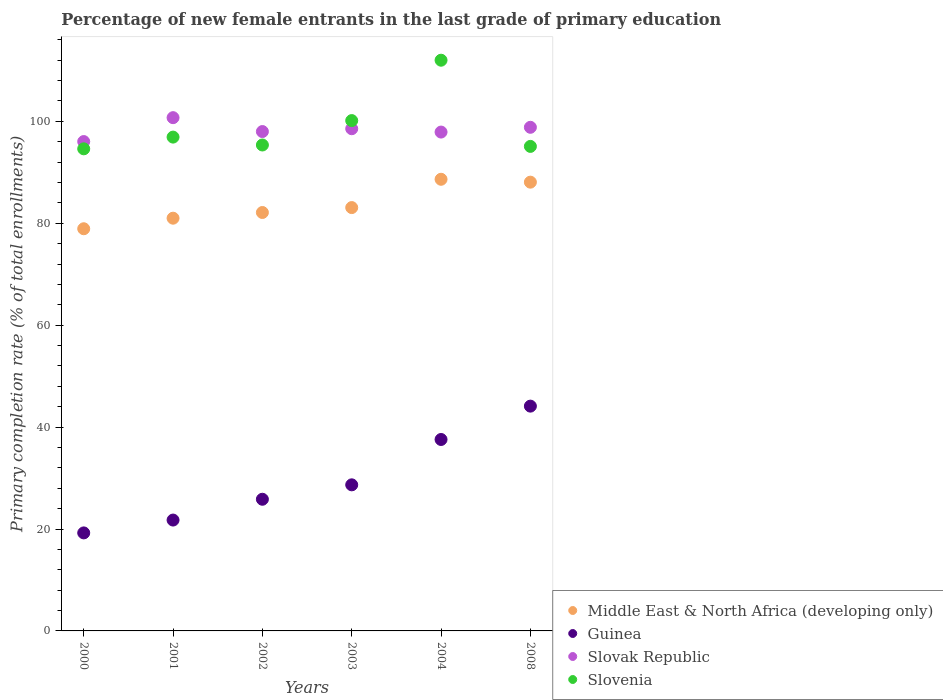How many different coloured dotlines are there?
Give a very brief answer. 4. What is the percentage of new female entrants in Middle East & North Africa (developing only) in 2001?
Your answer should be compact. 80.99. Across all years, what is the maximum percentage of new female entrants in Middle East & North Africa (developing only)?
Offer a terse response. 88.63. Across all years, what is the minimum percentage of new female entrants in Slovak Republic?
Make the answer very short. 96.03. In which year was the percentage of new female entrants in Slovenia maximum?
Give a very brief answer. 2004. What is the total percentage of new female entrants in Slovak Republic in the graph?
Make the answer very short. 590.02. What is the difference between the percentage of new female entrants in Middle East & North Africa (developing only) in 2003 and that in 2004?
Make the answer very short. -5.56. What is the difference between the percentage of new female entrants in Guinea in 2001 and the percentage of new female entrants in Middle East & North Africa (developing only) in 2000?
Your answer should be very brief. -57.17. What is the average percentage of new female entrants in Middle East & North Africa (developing only) per year?
Keep it short and to the point. 83.63. In the year 2008, what is the difference between the percentage of new female entrants in Guinea and percentage of new female entrants in Slovenia?
Your answer should be very brief. -50.97. In how many years, is the percentage of new female entrants in Slovak Republic greater than 20 %?
Provide a succinct answer. 6. What is the ratio of the percentage of new female entrants in Slovenia in 2003 to that in 2004?
Your answer should be compact. 0.89. Is the difference between the percentage of new female entrants in Guinea in 2000 and 2008 greater than the difference between the percentage of new female entrants in Slovenia in 2000 and 2008?
Offer a very short reply. No. What is the difference between the highest and the second highest percentage of new female entrants in Middle East & North Africa (developing only)?
Provide a short and direct response. 0.57. What is the difference between the highest and the lowest percentage of new female entrants in Middle East & North Africa (developing only)?
Your answer should be very brief. 9.71. Is it the case that in every year, the sum of the percentage of new female entrants in Guinea and percentage of new female entrants in Middle East & North Africa (developing only)  is greater than the sum of percentage of new female entrants in Slovak Republic and percentage of new female entrants in Slovenia?
Offer a terse response. No. Is it the case that in every year, the sum of the percentage of new female entrants in Middle East & North Africa (developing only) and percentage of new female entrants in Slovenia  is greater than the percentage of new female entrants in Slovak Republic?
Provide a short and direct response. Yes. Does the percentage of new female entrants in Slovenia monotonically increase over the years?
Offer a very short reply. No. Is the percentage of new female entrants in Slovak Republic strictly greater than the percentage of new female entrants in Slovenia over the years?
Ensure brevity in your answer.  No. Is the percentage of new female entrants in Slovak Republic strictly less than the percentage of new female entrants in Slovenia over the years?
Your response must be concise. No. How many dotlines are there?
Your answer should be very brief. 4. What is the difference between two consecutive major ticks on the Y-axis?
Offer a very short reply. 20. Are the values on the major ticks of Y-axis written in scientific E-notation?
Provide a short and direct response. No. Does the graph contain any zero values?
Offer a very short reply. No. Does the graph contain grids?
Provide a succinct answer. No. Where does the legend appear in the graph?
Your response must be concise. Bottom right. How many legend labels are there?
Your response must be concise. 4. How are the legend labels stacked?
Keep it short and to the point. Vertical. What is the title of the graph?
Make the answer very short. Percentage of new female entrants in the last grade of primary education. Does "Cambodia" appear as one of the legend labels in the graph?
Provide a short and direct response. No. What is the label or title of the X-axis?
Your answer should be compact. Years. What is the label or title of the Y-axis?
Your answer should be compact. Primary completion rate (% of total enrollments). What is the Primary completion rate (% of total enrollments) of Middle East & North Africa (developing only) in 2000?
Provide a short and direct response. 78.92. What is the Primary completion rate (% of total enrollments) of Guinea in 2000?
Offer a terse response. 19.23. What is the Primary completion rate (% of total enrollments) of Slovak Republic in 2000?
Keep it short and to the point. 96.03. What is the Primary completion rate (% of total enrollments) of Slovenia in 2000?
Ensure brevity in your answer.  94.61. What is the Primary completion rate (% of total enrollments) in Middle East & North Africa (developing only) in 2001?
Provide a succinct answer. 80.99. What is the Primary completion rate (% of total enrollments) of Guinea in 2001?
Give a very brief answer. 21.75. What is the Primary completion rate (% of total enrollments) in Slovak Republic in 2001?
Offer a very short reply. 100.72. What is the Primary completion rate (% of total enrollments) of Slovenia in 2001?
Provide a short and direct response. 96.91. What is the Primary completion rate (% of total enrollments) of Middle East & North Africa (developing only) in 2002?
Your answer should be very brief. 82.11. What is the Primary completion rate (% of total enrollments) in Guinea in 2002?
Ensure brevity in your answer.  25.84. What is the Primary completion rate (% of total enrollments) of Slovak Republic in 2002?
Offer a terse response. 98. What is the Primary completion rate (% of total enrollments) in Slovenia in 2002?
Make the answer very short. 95.36. What is the Primary completion rate (% of total enrollments) in Middle East & North Africa (developing only) in 2003?
Make the answer very short. 83.07. What is the Primary completion rate (% of total enrollments) in Guinea in 2003?
Keep it short and to the point. 28.67. What is the Primary completion rate (% of total enrollments) in Slovak Republic in 2003?
Your answer should be very brief. 98.55. What is the Primary completion rate (% of total enrollments) of Slovenia in 2003?
Offer a very short reply. 100.15. What is the Primary completion rate (% of total enrollments) of Middle East & North Africa (developing only) in 2004?
Your answer should be very brief. 88.63. What is the Primary completion rate (% of total enrollments) of Guinea in 2004?
Offer a terse response. 37.57. What is the Primary completion rate (% of total enrollments) of Slovak Republic in 2004?
Provide a succinct answer. 97.89. What is the Primary completion rate (% of total enrollments) in Slovenia in 2004?
Provide a succinct answer. 112. What is the Primary completion rate (% of total enrollments) of Middle East & North Africa (developing only) in 2008?
Make the answer very short. 88.06. What is the Primary completion rate (% of total enrollments) of Guinea in 2008?
Make the answer very short. 44.11. What is the Primary completion rate (% of total enrollments) of Slovak Republic in 2008?
Give a very brief answer. 98.83. What is the Primary completion rate (% of total enrollments) in Slovenia in 2008?
Ensure brevity in your answer.  95.08. Across all years, what is the maximum Primary completion rate (% of total enrollments) of Middle East & North Africa (developing only)?
Your response must be concise. 88.63. Across all years, what is the maximum Primary completion rate (% of total enrollments) in Guinea?
Your answer should be very brief. 44.11. Across all years, what is the maximum Primary completion rate (% of total enrollments) in Slovak Republic?
Ensure brevity in your answer.  100.72. Across all years, what is the maximum Primary completion rate (% of total enrollments) of Slovenia?
Offer a terse response. 112. Across all years, what is the minimum Primary completion rate (% of total enrollments) of Middle East & North Africa (developing only)?
Your answer should be very brief. 78.92. Across all years, what is the minimum Primary completion rate (% of total enrollments) of Guinea?
Ensure brevity in your answer.  19.23. Across all years, what is the minimum Primary completion rate (% of total enrollments) in Slovak Republic?
Provide a succinct answer. 96.03. Across all years, what is the minimum Primary completion rate (% of total enrollments) of Slovenia?
Keep it short and to the point. 94.61. What is the total Primary completion rate (% of total enrollments) in Middle East & North Africa (developing only) in the graph?
Ensure brevity in your answer.  501.79. What is the total Primary completion rate (% of total enrollments) of Guinea in the graph?
Offer a very short reply. 177.17. What is the total Primary completion rate (% of total enrollments) of Slovak Republic in the graph?
Give a very brief answer. 590.02. What is the total Primary completion rate (% of total enrollments) in Slovenia in the graph?
Your answer should be compact. 594.09. What is the difference between the Primary completion rate (% of total enrollments) of Middle East & North Africa (developing only) in 2000 and that in 2001?
Ensure brevity in your answer.  -2.07. What is the difference between the Primary completion rate (% of total enrollments) in Guinea in 2000 and that in 2001?
Your answer should be compact. -2.52. What is the difference between the Primary completion rate (% of total enrollments) in Slovak Republic in 2000 and that in 2001?
Your answer should be compact. -4.69. What is the difference between the Primary completion rate (% of total enrollments) of Slovenia in 2000 and that in 2001?
Give a very brief answer. -2.3. What is the difference between the Primary completion rate (% of total enrollments) in Middle East & North Africa (developing only) in 2000 and that in 2002?
Give a very brief answer. -3.19. What is the difference between the Primary completion rate (% of total enrollments) of Guinea in 2000 and that in 2002?
Your answer should be very brief. -6.6. What is the difference between the Primary completion rate (% of total enrollments) in Slovak Republic in 2000 and that in 2002?
Provide a succinct answer. -1.97. What is the difference between the Primary completion rate (% of total enrollments) in Slovenia in 2000 and that in 2002?
Your response must be concise. -0.75. What is the difference between the Primary completion rate (% of total enrollments) of Middle East & North Africa (developing only) in 2000 and that in 2003?
Provide a short and direct response. -4.15. What is the difference between the Primary completion rate (% of total enrollments) in Guinea in 2000 and that in 2003?
Your answer should be very brief. -9.43. What is the difference between the Primary completion rate (% of total enrollments) of Slovak Republic in 2000 and that in 2003?
Give a very brief answer. -2.52. What is the difference between the Primary completion rate (% of total enrollments) in Slovenia in 2000 and that in 2003?
Keep it short and to the point. -5.54. What is the difference between the Primary completion rate (% of total enrollments) in Middle East & North Africa (developing only) in 2000 and that in 2004?
Keep it short and to the point. -9.71. What is the difference between the Primary completion rate (% of total enrollments) of Guinea in 2000 and that in 2004?
Your answer should be very brief. -18.33. What is the difference between the Primary completion rate (% of total enrollments) in Slovak Republic in 2000 and that in 2004?
Provide a succinct answer. -1.86. What is the difference between the Primary completion rate (% of total enrollments) in Slovenia in 2000 and that in 2004?
Provide a succinct answer. -17.39. What is the difference between the Primary completion rate (% of total enrollments) in Middle East & North Africa (developing only) in 2000 and that in 2008?
Your answer should be compact. -9.14. What is the difference between the Primary completion rate (% of total enrollments) in Guinea in 2000 and that in 2008?
Provide a succinct answer. -24.88. What is the difference between the Primary completion rate (% of total enrollments) of Slovak Republic in 2000 and that in 2008?
Offer a very short reply. -2.8. What is the difference between the Primary completion rate (% of total enrollments) of Slovenia in 2000 and that in 2008?
Provide a short and direct response. -0.48. What is the difference between the Primary completion rate (% of total enrollments) of Middle East & North Africa (developing only) in 2001 and that in 2002?
Provide a short and direct response. -1.12. What is the difference between the Primary completion rate (% of total enrollments) of Guinea in 2001 and that in 2002?
Your answer should be compact. -4.08. What is the difference between the Primary completion rate (% of total enrollments) in Slovak Republic in 2001 and that in 2002?
Give a very brief answer. 2.72. What is the difference between the Primary completion rate (% of total enrollments) in Slovenia in 2001 and that in 2002?
Your response must be concise. 1.55. What is the difference between the Primary completion rate (% of total enrollments) of Middle East & North Africa (developing only) in 2001 and that in 2003?
Your response must be concise. -2.08. What is the difference between the Primary completion rate (% of total enrollments) of Guinea in 2001 and that in 2003?
Your response must be concise. -6.91. What is the difference between the Primary completion rate (% of total enrollments) in Slovak Republic in 2001 and that in 2003?
Give a very brief answer. 2.17. What is the difference between the Primary completion rate (% of total enrollments) of Slovenia in 2001 and that in 2003?
Your response must be concise. -3.24. What is the difference between the Primary completion rate (% of total enrollments) in Middle East & North Africa (developing only) in 2001 and that in 2004?
Give a very brief answer. -7.64. What is the difference between the Primary completion rate (% of total enrollments) of Guinea in 2001 and that in 2004?
Ensure brevity in your answer.  -15.81. What is the difference between the Primary completion rate (% of total enrollments) in Slovak Republic in 2001 and that in 2004?
Ensure brevity in your answer.  2.83. What is the difference between the Primary completion rate (% of total enrollments) of Slovenia in 2001 and that in 2004?
Keep it short and to the point. -15.09. What is the difference between the Primary completion rate (% of total enrollments) in Middle East & North Africa (developing only) in 2001 and that in 2008?
Give a very brief answer. -7.07. What is the difference between the Primary completion rate (% of total enrollments) in Guinea in 2001 and that in 2008?
Provide a succinct answer. -22.36. What is the difference between the Primary completion rate (% of total enrollments) of Slovak Republic in 2001 and that in 2008?
Your answer should be very brief. 1.89. What is the difference between the Primary completion rate (% of total enrollments) of Slovenia in 2001 and that in 2008?
Provide a succinct answer. 1.82. What is the difference between the Primary completion rate (% of total enrollments) in Middle East & North Africa (developing only) in 2002 and that in 2003?
Offer a very short reply. -0.96. What is the difference between the Primary completion rate (% of total enrollments) of Guinea in 2002 and that in 2003?
Keep it short and to the point. -2.83. What is the difference between the Primary completion rate (% of total enrollments) of Slovak Republic in 2002 and that in 2003?
Provide a succinct answer. -0.55. What is the difference between the Primary completion rate (% of total enrollments) of Slovenia in 2002 and that in 2003?
Make the answer very short. -4.79. What is the difference between the Primary completion rate (% of total enrollments) in Middle East & North Africa (developing only) in 2002 and that in 2004?
Your response must be concise. -6.52. What is the difference between the Primary completion rate (% of total enrollments) of Guinea in 2002 and that in 2004?
Keep it short and to the point. -11.73. What is the difference between the Primary completion rate (% of total enrollments) of Slovak Republic in 2002 and that in 2004?
Offer a terse response. 0.1. What is the difference between the Primary completion rate (% of total enrollments) of Slovenia in 2002 and that in 2004?
Your answer should be compact. -16.64. What is the difference between the Primary completion rate (% of total enrollments) in Middle East & North Africa (developing only) in 2002 and that in 2008?
Offer a terse response. -5.95. What is the difference between the Primary completion rate (% of total enrollments) of Guinea in 2002 and that in 2008?
Offer a terse response. -18.27. What is the difference between the Primary completion rate (% of total enrollments) of Slovak Republic in 2002 and that in 2008?
Offer a terse response. -0.83. What is the difference between the Primary completion rate (% of total enrollments) in Slovenia in 2002 and that in 2008?
Keep it short and to the point. 0.28. What is the difference between the Primary completion rate (% of total enrollments) in Middle East & North Africa (developing only) in 2003 and that in 2004?
Provide a succinct answer. -5.56. What is the difference between the Primary completion rate (% of total enrollments) in Guinea in 2003 and that in 2004?
Keep it short and to the point. -8.9. What is the difference between the Primary completion rate (% of total enrollments) of Slovak Republic in 2003 and that in 2004?
Your answer should be very brief. 0.65. What is the difference between the Primary completion rate (% of total enrollments) in Slovenia in 2003 and that in 2004?
Provide a short and direct response. -11.85. What is the difference between the Primary completion rate (% of total enrollments) in Middle East & North Africa (developing only) in 2003 and that in 2008?
Keep it short and to the point. -4.99. What is the difference between the Primary completion rate (% of total enrollments) of Guinea in 2003 and that in 2008?
Your answer should be compact. -15.44. What is the difference between the Primary completion rate (% of total enrollments) of Slovak Republic in 2003 and that in 2008?
Provide a short and direct response. -0.28. What is the difference between the Primary completion rate (% of total enrollments) in Slovenia in 2003 and that in 2008?
Give a very brief answer. 5.06. What is the difference between the Primary completion rate (% of total enrollments) of Middle East & North Africa (developing only) in 2004 and that in 2008?
Make the answer very short. 0.57. What is the difference between the Primary completion rate (% of total enrollments) in Guinea in 2004 and that in 2008?
Make the answer very short. -6.54. What is the difference between the Primary completion rate (% of total enrollments) of Slovak Republic in 2004 and that in 2008?
Keep it short and to the point. -0.94. What is the difference between the Primary completion rate (% of total enrollments) in Slovenia in 2004 and that in 2008?
Give a very brief answer. 16.91. What is the difference between the Primary completion rate (% of total enrollments) in Middle East & North Africa (developing only) in 2000 and the Primary completion rate (% of total enrollments) in Guinea in 2001?
Make the answer very short. 57.17. What is the difference between the Primary completion rate (% of total enrollments) in Middle East & North Africa (developing only) in 2000 and the Primary completion rate (% of total enrollments) in Slovak Republic in 2001?
Provide a succinct answer. -21.8. What is the difference between the Primary completion rate (% of total enrollments) in Middle East & North Africa (developing only) in 2000 and the Primary completion rate (% of total enrollments) in Slovenia in 2001?
Your answer should be very brief. -17.98. What is the difference between the Primary completion rate (% of total enrollments) of Guinea in 2000 and the Primary completion rate (% of total enrollments) of Slovak Republic in 2001?
Provide a short and direct response. -81.49. What is the difference between the Primary completion rate (% of total enrollments) in Guinea in 2000 and the Primary completion rate (% of total enrollments) in Slovenia in 2001?
Your answer should be compact. -77.67. What is the difference between the Primary completion rate (% of total enrollments) of Slovak Republic in 2000 and the Primary completion rate (% of total enrollments) of Slovenia in 2001?
Give a very brief answer. -0.88. What is the difference between the Primary completion rate (% of total enrollments) in Middle East & North Africa (developing only) in 2000 and the Primary completion rate (% of total enrollments) in Guinea in 2002?
Your response must be concise. 53.08. What is the difference between the Primary completion rate (% of total enrollments) in Middle East & North Africa (developing only) in 2000 and the Primary completion rate (% of total enrollments) in Slovak Republic in 2002?
Provide a short and direct response. -19.07. What is the difference between the Primary completion rate (% of total enrollments) in Middle East & North Africa (developing only) in 2000 and the Primary completion rate (% of total enrollments) in Slovenia in 2002?
Keep it short and to the point. -16.44. What is the difference between the Primary completion rate (% of total enrollments) in Guinea in 2000 and the Primary completion rate (% of total enrollments) in Slovak Republic in 2002?
Your answer should be compact. -78.76. What is the difference between the Primary completion rate (% of total enrollments) in Guinea in 2000 and the Primary completion rate (% of total enrollments) in Slovenia in 2002?
Offer a very short reply. -76.12. What is the difference between the Primary completion rate (% of total enrollments) of Slovak Republic in 2000 and the Primary completion rate (% of total enrollments) of Slovenia in 2002?
Provide a succinct answer. 0.67. What is the difference between the Primary completion rate (% of total enrollments) in Middle East & North Africa (developing only) in 2000 and the Primary completion rate (% of total enrollments) in Guinea in 2003?
Keep it short and to the point. 50.25. What is the difference between the Primary completion rate (% of total enrollments) in Middle East & North Africa (developing only) in 2000 and the Primary completion rate (% of total enrollments) in Slovak Republic in 2003?
Your answer should be very brief. -19.63. What is the difference between the Primary completion rate (% of total enrollments) of Middle East & North Africa (developing only) in 2000 and the Primary completion rate (% of total enrollments) of Slovenia in 2003?
Provide a succinct answer. -21.22. What is the difference between the Primary completion rate (% of total enrollments) of Guinea in 2000 and the Primary completion rate (% of total enrollments) of Slovak Republic in 2003?
Give a very brief answer. -79.31. What is the difference between the Primary completion rate (% of total enrollments) of Guinea in 2000 and the Primary completion rate (% of total enrollments) of Slovenia in 2003?
Give a very brief answer. -80.91. What is the difference between the Primary completion rate (% of total enrollments) in Slovak Republic in 2000 and the Primary completion rate (% of total enrollments) in Slovenia in 2003?
Keep it short and to the point. -4.12. What is the difference between the Primary completion rate (% of total enrollments) of Middle East & North Africa (developing only) in 2000 and the Primary completion rate (% of total enrollments) of Guinea in 2004?
Give a very brief answer. 41.35. What is the difference between the Primary completion rate (% of total enrollments) in Middle East & North Africa (developing only) in 2000 and the Primary completion rate (% of total enrollments) in Slovak Republic in 2004?
Keep it short and to the point. -18.97. What is the difference between the Primary completion rate (% of total enrollments) in Middle East & North Africa (developing only) in 2000 and the Primary completion rate (% of total enrollments) in Slovenia in 2004?
Offer a terse response. -33.07. What is the difference between the Primary completion rate (% of total enrollments) in Guinea in 2000 and the Primary completion rate (% of total enrollments) in Slovak Republic in 2004?
Your answer should be very brief. -78.66. What is the difference between the Primary completion rate (% of total enrollments) in Guinea in 2000 and the Primary completion rate (% of total enrollments) in Slovenia in 2004?
Keep it short and to the point. -92.76. What is the difference between the Primary completion rate (% of total enrollments) of Slovak Republic in 2000 and the Primary completion rate (% of total enrollments) of Slovenia in 2004?
Give a very brief answer. -15.97. What is the difference between the Primary completion rate (% of total enrollments) in Middle East & North Africa (developing only) in 2000 and the Primary completion rate (% of total enrollments) in Guinea in 2008?
Make the answer very short. 34.81. What is the difference between the Primary completion rate (% of total enrollments) in Middle East & North Africa (developing only) in 2000 and the Primary completion rate (% of total enrollments) in Slovak Republic in 2008?
Your answer should be compact. -19.91. What is the difference between the Primary completion rate (% of total enrollments) in Middle East & North Africa (developing only) in 2000 and the Primary completion rate (% of total enrollments) in Slovenia in 2008?
Provide a short and direct response. -16.16. What is the difference between the Primary completion rate (% of total enrollments) in Guinea in 2000 and the Primary completion rate (% of total enrollments) in Slovak Republic in 2008?
Offer a very short reply. -79.6. What is the difference between the Primary completion rate (% of total enrollments) in Guinea in 2000 and the Primary completion rate (% of total enrollments) in Slovenia in 2008?
Ensure brevity in your answer.  -75.85. What is the difference between the Primary completion rate (% of total enrollments) of Slovak Republic in 2000 and the Primary completion rate (% of total enrollments) of Slovenia in 2008?
Give a very brief answer. 0.95. What is the difference between the Primary completion rate (% of total enrollments) of Middle East & North Africa (developing only) in 2001 and the Primary completion rate (% of total enrollments) of Guinea in 2002?
Your response must be concise. 55.16. What is the difference between the Primary completion rate (% of total enrollments) of Middle East & North Africa (developing only) in 2001 and the Primary completion rate (% of total enrollments) of Slovak Republic in 2002?
Provide a short and direct response. -17. What is the difference between the Primary completion rate (% of total enrollments) of Middle East & North Africa (developing only) in 2001 and the Primary completion rate (% of total enrollments) of Slovenia in 2002?
Offer a very short reply. -14.36. What is the difference between the Primary completion rate (% of total enrollments) of Guinea in 2001 and the Primary completion rate (% of total enrollments) of Slovak Republic in 2002?
Keep it short and to the point. -76.24. What is the difference between the Primary completion rate (% of total enrollments) in Guinea in 2001 and the Primary completion rate (% of total enrollments) in Slovenia in 2002?
Ensure brevity in your answer.  -73.6. What is the difference between the Primary completion rate (% of total enrollments) of Slovak Republic in 2001 and the Primary completion rate (% of total enrollments) of Slovenia in 2002?
Give a very brief answer. 5.36. What is the difference between the Primary completion rate (% of total enrollments) in Middle East & North Africa (developing only) in 2001 and the Primary completion rate (% of total enrollments) in Guinea in 2003?
Provide a short and direct response. 52.33. What is the difference between the Primary completion rate (% of total enrollments) of Middle East & North Africa (developing only) in 2001 and the Primary completion rate (% of total enrollments) of Slovak Republic in 2003?
Ensure brevity in your answer.  -17.56. What is the difference between the Primary completion rate (% of total enrollments) in Middle East & North Africa (developing only) in 2001 and the Primary completion rate (% of total enrollments) in Slovenia in 2003?
Provide a succinct answer. -19.15. What is the difference between the Primary completion rate (% of total enrollments) of Guinea in 2001 and the Primary completion rate (% of total enrollments) of Slovak Republic in 2003?
Ensure brevity in your answer.  -76.79. What is the difference between the Primary completion rate (% of total enrollments) in Guinea in 2001 and the Primary completion rate (% of total enrollments) in Slovenia in 2003?
Ensure brevity in your answer.  -78.39. What is the difference between the Primary completion rate (% of total enrollments) of Slovak Republic in 2001 and the Primary completion rate (% of total enrollments) of Slovenia in 2003?
Ensure brevity in your answer.  0.57. What is the difference between the Primary completion rate (% of total enrollments) of Middle East & North Africa (developing only) in 2001 and the Primary completion rate (% of total enrollments) of Guinea in 2004?
Your response must be concise. 43.43. What is the difference between the Primary completion rate (% of total enrollments) in Middle East & North Africa (developing only) in 2001 and the Primary completion rate (% of total enrollments) in Slovak Republic in 2004?
Your answer should be compact. -16.9. What is the difference between the Primary completion rate (% of total enrollments) of Middle East & North Africa (developing only) in 2001 and the Primary completion rate (% of total enrollments) of Slovenia in 2004?
Provide a succinct answer. -31. What is the difference between the Primary completion rate (% of total enrollments) in Guinea in 2001 and the Primary completion rate (% of total enrollments) in Slovak Republic in 2004?
Your answer should be compact. -76.14. What is the difference between the Primary completion rate (% of total enrollments) in Guinea in 2001 and the Primary completion rate (% of total enrollments) in Slovenia in 2004?
Make the answer very short. -90.24. What is the difference between the Primary completion rate (% of total enrollments) in Slovak Republic in 2001 and the Primary completion rate (% of total enrollments) in Slovenia in 2004?
Give a very brief answer. -11.28. What is the difference between the Primary completion rate (% of total enrollments) of Middle East & North Africa (developing only) in 2001 and the Primary completion rate (% of total enrollments) of Guinea in 2008?
Give a very brief answer. 36.88. What is the difference between the Primary completion rate (% of total enrollments) in Middle East & North Africa (developing only) in 2001 and the Primary completion rate (% of total enrollments) in Slovak Republic in 2008?
Provide a short and direct response. -17.84. What is the difference between the Primary completion rate (% of total enrollments) of Middle East & North Africa (developing only) in 2001 and the Primary completion rate (% of total enrollments) of Slovenia in 2008?
Your response must be concise. -14.09. What is the difference between the Primary completion rate (% of total enrollments) of Guinea in 2001 and the Primary completion rate (% of total enrollments) of Slovak Republic in 2008?
Offer a terse response. -77.08. What is the difference between the Primary completion rate (% of total enrollments) in Guinea in 2001 and the Primary completion rate (% of total enrollments) in Slovenia in 2008?
Provide a succinct answer. -73.33. What is the difference between the Primary completion rate (% of total enrollments) of Slovak Republic in 2001 and the Primary completion rate (% of total enrollments) of Slovenia in 2008?
Ensure brevity in your answer.  5.64. What is the difference between the Primary completion rate (% of total enrollments) in Middle East & North Africa (developing only) in 2002 and the Primary completion rate (% of total enrollments) in Guinea in 2003?
Provide a succinct answer. 53.44. What is the difference between the Primary completion rate (% of total enrollments) of Middle East & North Africa (developing only) in 2002 and the Primary completion rate (% of total enrollments) of Slovak Republic in 2003?
Your answer should be very brief. -16.44. What is the difference between the Primary completion rate (% of total enrollments) in Middle East & North Africa (developing only) in 2002 and the Primary completion rate (% of total enrollments) in Slovenia in 2003?
Offer a very short reply. -18.04. What is the difference between the Primary completion rate (% of total enrollments) in Guinea in 2002 and the Primary completion rate (% of total enrollments) in Slovak Republic in 2003?
Keep it short and to the point. -72.71. What is the difference between the Primary completion rate (% of total enrollments) in Guinea in 2002 and the Primary completion rate (% of total enrollments) in Slovenia in 2003?
Your answer should be very brief. -74.31. What is the difference between the Primary completion rate (% of total enrollments) in Slovak Republic in 2002 and the Primary completion rate (% of total enrollments) in Slovenia in 2003?
Provide a succinct answer. -2.15. What is the difference between the Primary completion rate (% of total enrollments) of Middle East & North Africa (developing only) in 2002 and the Primary completion rate (% of total enrollments) of Guinea in 2004?
Your answer should be very brief. 44.54. What is the difference between the Primary completion rate (% of total enrollments) in Middle East & North Africa (developing only) in 2002 and the Primary completion rate (% of total enrollments) in Slovak Republic in 2004?
Your answer should be compact. -15.78. What is the difference between the Primary completion rate (% of total enrollments) in Middle East & North Africa (developing only) in 2002 and the Primary completion rate (% of total enrollments) in Slovenia in 2004?
Provide a short and direct response. -29.89. What is the difference between the Primary completion rate (% of total enrollments) in Guinea in 2002 and the Primary completion rate (% of total enrollments) in Slovak Republic in 2004?
Offer a terse response. -72.06. What is the difference between the Primary completion rate (% of total enrollments) of Guinea in 2002 and the Primary completion rate (% of total enrollments) of Slovenia in 2004?
Your answer should be very brief. -86.16. What is the difference between the Primary completion rate (% of total enrollments) in Slovak Republic in 2002 and the Primary completion rate (% of total enrollments) in Slovenia in 2004?
Keep it short and to the point. -14. What is the difference between the Primary completion rate (% of total enrollments) of Middle East & North Africa (developing only) in 2002 and the Primary completion rate (% of total enrollments) of Guinea in 2008?
Your answer should be very brief. 38. What is the difference between the Primary completion rate (% of total enrollments) in Middle East & North Africa (developing only) in 2002 and the Primary completion rate (% of total enrollments) in Slovak Republic in 2008?
Keep it short and to the point. -16.72. What is the difference between the Primary completion rate (% of total enrollments) of Middle East & North Africa (developing only) in 2002 and the Primary completion rate (% of total enrollments) of Slovenia in 2008?
Keep it short and to the point. -12.97. What is the difference between the Primary completion rate (% of total enrollments) in Guinea in 2002 and the Primary completion rate (% of total enrollments) in Slovak Republic in 2008?
Offer a very short reply. -72.99. What is the difference between the Primary completion rate (% of total enrollments) in Guinea in 2002 and the Primary completion rate (% of total enrollments) in Slovenia in 2008?
Provide a succinct answer. -69.24. What is the difference between the Primary completion rate (% of total enrollments) in Slovak Republic in 2002 and the Primary completion rate (% of total enrollments) in Slovenia in 2008?
Keep it short and to the point. 2.91. What is the difference between the Primary completion rate (% of total enrollments) of Middle East & North Africa (developing only) in 2003 and the Primary completion rate (% of total enrollments) of Guinea in 2004?
Give a very brief answer. 45.51. What is the difference between the Primary completion rate (% of total enrollments) in Middle East & North Africa (developing only) in 2003 and the Primary completion rate (% of total enrollments) in Slovak Republic in 2004?
Your response must be concise. -14.82. What is the difference between the Primary completion rate (% of total enrollments) in Middle East & North Africa (developing only) in 2003 and the Primary completion rate (% of total enrollments) in Slovenia in 2004?
Offer a very short reply. -28.92. What is the difference between the Primary completion rate (% of total enrollments) in Guinea in 2003 and the Primary completion rate (% of total enrollments) in Slovak Republic in 2004?
Provide a short and direct response. -69.23. What is the difference between the Primary completion rate (% of total enrollments) of Guinea in 2003 and the Primary completion rate (% of total enrollments) of Slovenia in 2004?
Your answer should be very brief. -83.33. What is the difference between the Primary completion rate (% of total enrollments) in Slovak Republic in 2003 and the Primary completion rate (% of total enrollments) in Slovenia in 2004?
Provide a succinct answer. -13.45. What is the difference between the Primary completion rate (% of total enrollments) in Middle East & North Africa (developing only) in 2003 and the Primary completion rate (% of total enrollments) in Guinea in 2008?
Keep it short and to the point. 38.96. What is the difference between the Primary completion rate (% of total enrollments) of Middle East & North Africa (developing only) in 2003 and the Primary completion rate (% of total enrollments) of Slovak Republic in 2008?
Your answer should be very brief. -15.76. What is the difference between the Primary completion rate (% of total enrollments) of Middle East & North Africa (developing only) in 2003 and the Primary completion rate (% of total enrollments) of Slovenia in 2008?
Your answer should be very brief. -12.01. What is the difference between the Primary completion rate (% of total enrollments) in Guinea in 2003 and the Primary completion rate (% of total enrollments) in Slovak Republic in 2008?
Your response must be concise. -70.16. What is the difference between the Primary completion rate (% of total enrollments) in Guinea in 2003 and the Primary completion rate (% of total enrollments) in Slovenia in 2008?
Make the answer very short. -66.41. What is the difference between the Primary completion rate (% of total enrollments) in Slovak Republic in 2003 and the Primary completion rate (% of total enrollments) in Slovenia in 2008?
Provide a short and direct response. 3.47. What is the difference between the Primary completion rate (% of total enrollments) in Middle East & North Africa (developing only) in 2004 and the Primary completion rate (% of total enrollments) in Guinea in 2008?
Offer a terse response. 44.52. What is the difference between the Primary completion rate (% of total enrollments) of Middle East & North Africa (developing only) in 2004 and the Primary completion rate (% of total enrollments) of Slovenia in 2008?
Your answer should be very brief. -6.45. What is the difference between the Primary completion rate (% of total enrollments) in Guinea in 2004 and the Primary completion rate (% of total enrollments) in Slovak Republic in 2008?
Give a very brief answer. -61.26. What is the difference between the Primary completion rate (% of total enrollments) of Guinea in 2004 and the Primary completion rate (% of total enrollments) of Slovenia in 2008?
Ensure brevity in your answer.  -57.52. What is the difference between the Primary completion rate (% of total enrollments) of Slovak Republic in 2004 and the Primary completion rate (% of total enrollments) of Slovenia in 2008?
Make the answer very short. 2.81. What is the average Primary completion rate (% of total enrollments) in Middle East & North Africa (developing only) per year?
Keep it short and to the point. 83.63. What is the average Primary completion rate (% of total enrollments) in Guinea per year?
Keep it short and to the point. 29.53. What is the average Primary completion rate (% of total enrollments) in Slovak Republic per year?
Ensure brevity in your answer.  98.34. What is the average Primary completion rate (% of total enrollments) in Slovenia per year?
Give a very brief answer. 99.02. In the year 2000, what is the difference between the Primary completion rate (% of total enrollments) of Middle East & North Africa (developing only) and Primary completion rate (% of total enrollments) of Guinea?
Offer a terse response. 59.69. In the year 2000, what is the difference between the Primary completion rate (% of total enrollments) in Middle East & North Africa (developing only) and Primary completion rate (% of total enrollments) in Slovak Republic?
Your response must be concise. -17.11. In the year 2000, what is the difference between the Primary completion rate (% of total enrollments) of Middle East & North Africa (developing only) and Primary completion rate (% of total enrollments) of Slovenia?
Your response must be concise. -15.68. In the year 2000, what is the difference between the Primary completion rate (% of total enrollments) in Guinea and Primary completion rate (% of total enrollments) in Slovak Republic?
Offer a very short reply. -76.8. In the year 2000, what is the difference between the Primary completion rate (% of total enrollments) of Guinea and Primary completion rate (% of total enrollments) of Slovenia?
Ensure brevity in your answer.  -75.37. In the year 2000, what is the difference between the Primary completion rate (% of total enrollments) of Slovak Republic and Primary completion rate (% of total enrollments) of Slovenia?
Give a very brief answer. 1.42. In the year 2001, what is the difference between the Primary completion rate (% of total enrollments) of Middle East & North Africa (developing only) and Primary completion rate (% of total enrollments) of Guinea?
Offer a very short reply. 59.24. In the year 2001, what is the difference between the Primary completion rate (% of total enrollments) of Middle East & North Africa (developing only) and Primary completion rate (% of total enrollments) of Slovak Republic?
Your answer should be very brief. -19.73. In the year 2001, what is the difference between the Primary completion rate (% of total enrollments) of Middle East & North Africa (developing only) and Primary completion rate (% of total enrollments) of Slovenia?
Give a very brief answer. -15.91. In the year 2001, what is the difference between the Primary completion rate (% of total enrollments) of Guinea and Primary completion rate (% of total enrollments) of Slovak Republic?
Make the answer very short. -78.97. In the year 2001, what is the difference between the Primary completion rate (% of total enrollments) of Guinea and Primary completion rate (% of total enrollments) of Slovenia?
Provide a short and direct response. -75.15. In the year 2001, what is the difference between the Primary completion rate (% of total enrollments) of Slovak Republic and Primary completion rate (% of total enrollments) of Slovenia?
Offer a very short reply. 3.81. In the year 2002, what is the difference between the Primary completion rate (% of total enrollments) of Middle East & North Africa (developing only) and Primary completion rate (% of total enrollments) of Guinea?
Provide a succinct answer. 56.27. In the year 2002, what is the difference between the Primary completion rate (% of total enrollments) of Middle East & North Africa (developing only) and Primary completion rate (% of total enrollments) of Slovak Republic?
Ensure brevity in your answer.  -15.89. In the year 2002, what is the difference between the Primary completion rate (% of total enrollments) of Middle East & North Africa (developing only) and Primary completion rate (% of total enrollments) of Slovenia?
Give a very brief answer. -13.25. In the year 2002, what is the difference between the Primary completion rate (% of total enrollments) in Guinea and Primary completion rate (% of total enrollments) in Slovak Republic?
Offer a very short reply. -72.16. In the year 2002, what is the difference between the Primary completion rate (% of total enrollments) of Guinea and Primary completion rate (% of total enrollments) of Slovenia?
Your answer should be compact. -69.52. In the year 2002, what is the difference between the Primary completion rate (% of total enrollments) of Slovak Republic and Primary completion rate (% of total enrollments) of Slovenia?
Provide a short and direct response. 2.64. In the year 2003, what is the difference between the Primary completion rate (% of total enrollments) in Middle East & North Africa (developing only) and Primary completion rate (% of total enrollments) in Guinea?
Give a very brief answer. 54.41. In the year 2003, what is the difference between the Primary completion rate (% of total enrollments) in Middle East & North Africa (developing only) and Primary completion rate (% of total enrollments) in Slovak Republic?
Provide a short and direct response. -15.47. In the year 2003, what is the difference between the Primary completion rate (% of total enrollments) in Middle East & North Africa (developing only) and Primary completion rate (% of total enrollments) in Slovenia?
Keep it short and to the point. -17.07. In the year 2003, what is the difference between the Primary completion rate (% of total enrollments) of Guinea and Primary completion rate (% of total enrollments) of Slovak Republic?
Give a very brief answer. -69.88. In the year 2003, what is the difference between the Primary completion rate (% of total enrollments) of Guinea and Primary completion rate (% of total enrollments) of Slovenia?
Your response must be concise. -71.48. In the year 2003, what is the difference between the Primary completion rate (% of total enrollments) of Slovak Republic and Primary completion rate (% of total enrollments) of Slovenia?
Your answer should be compact. -1.6. In the year 2004, what is the difference between the Primary completion rate (% of total enrollments) in Middle East & North Africa (developing only) and Primary completion rate (% of total enrollments) in Guinea?
Offer a very short reply. 51.06. In the year 2004, what is the difference between the Primary completion rate (% of total enrollments) in Middle East & North Africa (developing only) and Primary completion rate (% of total enrollments) in Slovak Republic?
Provide a succinct answer. -9.26. In the year 2004, what is the difference between the Primary completion rate (% of total enrollments) of Middle East & North Africa (developing only) and Primary completion rate (% of total enrollments) of Slovenia?
Provide a short and direct response. -23.37. In the year 2004, what is the difference between the Primary completion rate (% of total enrollments) in Guinea and Primary completion rate (% of total enrollments) in Slovak Republic?
Provide a succinct answer. -60.33. In the year 2004, what is the difference between the Primary completion rate (% of total enrollments) of Guinea and Primary completion rate (% of total enrollments) of Slovenia?
Offer a terse response. -74.43. In the year 2004, what is the difference between the Primary completion rate (% of total enrollments) of Slovak Republic and Primary completion rate (% of total enrollments) of Slovenia?
Keep it short and to the point. -14.1. In the year 2008, what is the difference between the Primary completion rate (% of total enrollments) in Middle East & North Africa (developing only) and Primary completion rate (% of total enrollments) in Guinea?
Provide a short and direct response. 43.95. In the year 2008, what is the difference between the Primary completion rate (% of total enrollments) of Middle East & North Africa (developing only) and Primary completion rate (% of total enrollments) of Slovak Republic?
Offer a terse response. -10.77. In the year 2008, what is the difference between the Primary completion rate (% of total enrollments) in Middle East & North Africa (developing only) and Primary completion rate (% of total enrollments) in Slovenia?
Your answer should be compact. -7.02. In the year 2008, what is the difference between the Primary completion rate (% of total enrollments) of Guinea and Primary completion rate (% of total enrollments) of Slovak Republic?
Your answer should be very brief. -54.72. In the year 2008, what is the difference between the Primary completion rate (% of total enrollments) in Guinea and Primary completion rate (% of total enrollments) in Slovenia?
Provide a succinct answer. -50.97. In the year 2008, what is the difference between the Primary completion rate (% of total enrollments) in Slovak Republic and Primary completion rate (% of total enrollments) in Slovenia?
Make the answer very short. 3.75. What is the ratio of the Primary completion rate (% of total enrollments) of Middle East & North Africa (developing only) in 2000 to that in 2001?
Offer a terse response. 0.97. What is the ratio of the Primary completion rate (% of total enrollments) of Guinea in 2000 to that in 2001?
Your response must be concise. 0.88. What is the ratio of the Primary completion rate (% of total enrollments) of Slovak Republic in 2000 to that in 2001?
Make the answer very short. 0.95. What is the ratio of the Primary completion rate (% of total enrollments) in Slovenia in 2000 to that in 2001?
Your answer should be very brief. 0.98. What is the ratio of the Primary completion rate (% of total enrollments) in Middle East & North Africa (developing only) in 2000 to that in 2002?
Provide a succinct answer. 0.96. What is the ratio of the Primary completion rate (% of total enrollments) of Guinea in 2000 to that in 2002?
Provide a short and direct response. 0.74. What is the ratio of the Primary completion rate (% of total enrollments) in Slovak Republic in 2000 to that in 2002?
Make the answer very short. 0.98. What is the ratio of the Primary completion rate (% of total enrollments) of Slovenia in 2000 to that in 2002?
Make the answer very short. 0.99. What is the ratio of the Primary completion rate (% of total enrollments) of Guinea in 2000 to that in 2003?
Make the answer very short. 0.67. What is the ratio of the Primary completion rate (% of total enrollments) in Slovak Republic in 2000 to that in 2003?
Ensure brevity in your answer.  0.97. What is the ratio of the Primary completion rate (% of total enrollments) in Slovenia in 2000 to that in 2003?
Provide a short and direct response. 0.94. What is the ratio of the Primary completion rate (% of total enrollments) in Middle East & North Africa (developing only) in 2000 to that in 2004?
Your answer should be compact. 0.89. What is the ratio of the Primary completion rate (% of total enrollments) of Guinea in 2000 to that in 2004?
Give a very brief answer. 0.51. What is the ratio of the Primary completion rate (% of total enrollments) in Slovak Republic in 2000 to that in 2004?
Keep it short and to the point. 0.98. What is the ratio of the Primary completion rate (% of total enrollments) in Slovenia in 2000 to that in 2004?
Your answer should be compact. 0.84. What is the ratio of the Primary completion rate (% of total enrollments) of Middle East & North Africa (developing only) in 2000 to that in 2008?
Keep it short and to the point. 0.9. What is the ratio of the Primary completion rate (% of total enrollments) of Guinea in 2000 to that in 2008?
Offer a terse response. 0.44. What is the ratio of the Primary completion rate (% of total enrollments) in Slovak Republic in 2000 to that in 2008?
Make the answer very short. 0.97. What is the ratio of the Primary completion rate (% of total enrollments) in Middle East & North Africa (developing only) in 2001 to that in 2002?
Keep it short and to the point. 0.99. What is the ratio of the Primary completion rate (% of total enrollments) in Guinea in 2001 to that in 2002?
Offer a terse response. 0.84. What is the ratio of the Primary completion rate (% of total enrollments) of Slovak Republic in 2001 to that in 2002?
Provide a succinct answer. 1.03. What is the ratio of the Primary completion rate (% of total enrollments) in Slovenia in 2001 to that in 2002?
Your answer should be very brief. 1.02. What is the ratio of the Primary completion rate (% of total enrollments) of Middle East & North Africa (developing only) in 2001 to that in 2003?
Provide a succinct answer. 0.97. What is the ratio of the Primary completion rate (% of total enrollments) in Guinea in 2001 to that in 2003?
Provide a succinct answer. 0.76. What is the ratio of the Primary completion rate (% of total enrollments) in Slovak Republic in 2001 to that in 2003?
Your answer should be very brief. 1.02. What is the ratio of the Primary completion rate (% of total enrollments) of Slovenia in 2001 to that in 2003?
Keep it short and to the point. 0.97. What is the ratio of the Primary completion rate (% of total enrollments) in Middle East & North Africa (developing only) in 2001 to that in 2004?
Offer a very short reply. 0.91. What is the ratio of the Primary completion rate (% of total enrollments) in Guinea in 2001 to that in 2004?
Offer a very short reply. 0.58. What is the ratio of the Primary completion rate (% of total enrollments) in Slovak Republic in 2001 to that in 2004?
Offer a terse response. 1.03. What is the ratio of the Primary completion rate (% of total enrollments) of Slovenia in 2001 to that in 2004?
Your response must be concise. 0.87. What is the ratio of the Primary completion rate (% of total enrollments) of Middle East & North Africa (developing only) in 2001 to that in 2008?
Your response must be concise. 0.92. What is the ratio of the Primary completion rate (% of total enrollments) in Guinea in 2001 to that in 2008?
Make the answer very short. 0.49. What is the ratio of the Primary completion rate (% of total enrollments) of Slovak Republic in 2001 to that in 2008?
Provide a succinct answer. 1.02. What is the ratio of the Primary completion rate (% of total enrollments) of Slovenia in 2001 to that in 2008?
Provide a succinct answer. 1.02. What is the ratio of the Primary completion rate (% of total enrollments) in Middle East & North Africa (developing only) in 2002 to that in 2003?
Provide a succinct answer. 0.99. What is the ratio of the Primary completion rate (% of total enrollments) in Guinea in 2002 to that in 2003?
Offer a terse response. 0.9. What is the ratio of the Primary completion rate (% of total enrollments) in Slovak Republic in 2002 to that in 2003?
Keep it short and to the point. 0.99. What is the ratio of the Primary completion rate (% of total enrollments) of Slovenia in 2002 to that in 2003?
Make the answer very short. 0.95. What is the ratio of the Primary completion rate (% of total enrollments) in Middle East & North Africa (developing only) in 2002 to that in 2004?
Provide a short and direct response. 0.93. What is the ratio of the Primary completion rate (% of total enrollments) of Guinea in 2002 to that in 2004?
Offer a very short reply. 0.69. What is the ratio of the Primary completion rate (% of total enrollments) in Slovak Republic in 2002 to that in 2004?
Ensure brevity in your answer.  1. What is the ratio of the Primary completion rate (% of total enrollments) of Slovenia in 2002 to that in 2004?
Keep it short and to the point. 0.85. What is the ratio of the Primary completion rate (% of total enrollments) of Middle East & North Africa (developing only) in 2002 to that in 2008?
Give a very brief answer. 0.93. What is the ratio of the Primary completion rate (% of total enrollments) in Guinea in 2002 to that in 2008?
Make the answer very short. 0.59. What is the ratio of the Primary completion rate (% of total enrollments) of Middle East & North Africa (developing only) in 2003 to that in 2004?
Provide a short and direct response. 0.94. What is the ratio of the Primary completion rate (% of total enrollments) of Guinea in 2003 to that in 2004?
Provide a succinct answer. 0.76. What is the ratio of the Primary completion rate (% of total enrollments) in Slovenia in 2003 to that in 2004?
Keep it short and to the point. 0.89. What is the ratio of the Primary completion rate (% of total enrollments) of Middle East & North Africa (developing only) in 2003 to that in 2008?
Ensure brevity in your answer.  0.94. What is the ratio of the Primary completion rate (% of total enrollments) of Guinea in 2003 to that in 2008?
Provide a succinct answer. 0.65. What is the ratio of the Primary completion rate (% of total enrollments) of Slovak Republic in 2003 to that in 2008?
Provide a short and direct response. 1. What is the ratio of the Primary completion rate (% of total enrollments) of Slovenia in 2003 to that in 2008?
Keep it short and to the point. 1.05. What is the ratio of the Primary completion rate (% of total enrollments) of Middle East & North Africa (developing only) in 2004 to that in 2008?
Your answer should be very brief. 1.01. What is the ratio of the Primary completion rate (% of total enrollments) in Guinea in 2004 to that in 2008?
Provide a succinct answer. 0.85. What is the ratio of the Primary completion rate (% of total enrollments) of Slovak Republic in 2004 to that in 2008?
Provide a short and direct response. 0.99. What is the ratio of the Primary completion rate (% of total enrollments) in Slovenia in 2004 to that in 2008?
Keep it short and to the point. 1.18. What is the difference between the highest and the second highest Primary completion rate (% of total enrollments) of Middle East & North Africa (developing only)?
Your answer should be very brief. 0.57. What is the difference between the highest and the second highest Primary completion rate (% of total enrollments) of Guinea?
Give a very brief answer. 6.54. What is the difference between the highest and the second highest Primary completion rate (% of total enrollments) in Slovak Republic?
Your response must be concise. 1.89. What is the difference between the highest and the second highest Primary completion rate (% of total enrollments) of Slovenia?
Provide a short and direct response. 11.85. What is the difference between the highest and the lowest Primary completion rate (% of total enrollments) of Middle East & North Africa (developing only)?
Ensure brevity in your answer.  9.71. What is the difference between the highest and the lowest Primary completion rate (% of total enrollments) of Guinea?
Keep it short and to the point. 24.88. What is the difference between the highest and the lowest Primary completion rate (% of total enrollments) in Slovak Republic?
Your response must be concise. 4.69. What is the difference between the highest and the lowest Primary completion rate (% of total enrollments) in Slovenia?
Your response must be concise. 17.39. 